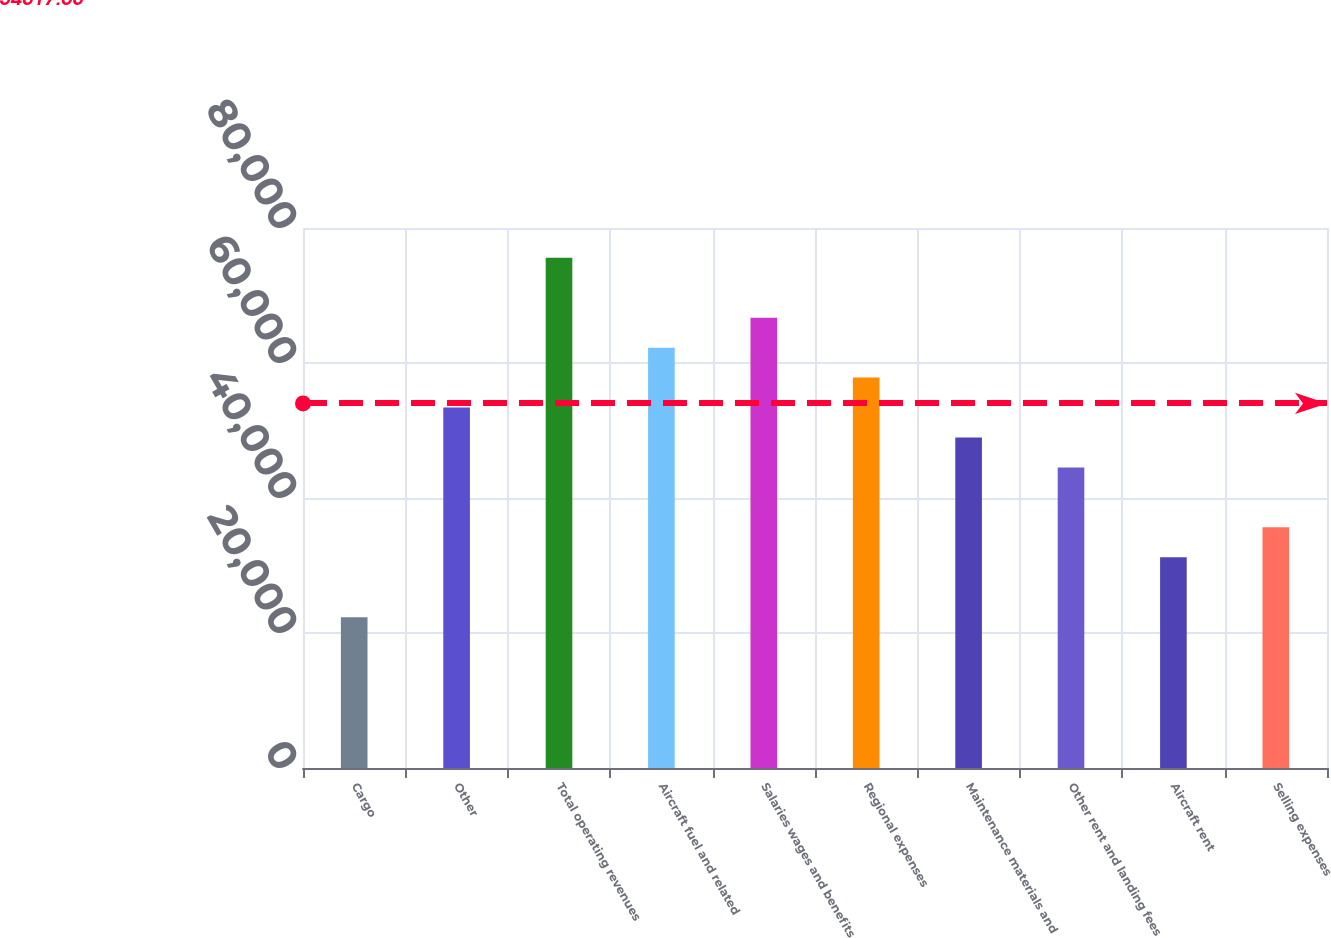<chart> <loc_0><loc_0><loc_500><loc_500><bar_chart><fcel>Cargo<fcel>Other<fcel>Total operating revenues<fcel>Aircraft fuel and related<fcel>Salaries wages and benefits<fcel>Regional expenses<fcel>Maintenance materials and<fcel>Other rent and landing fees<fcel>Aircraft rent<fcel>Selling expenses<nl><fcel>22348.5<fcel>53402.6<fcel>75584.1<fcel>62275.2<fcel>66711.5<fcel>57838.9<fcel>48966.3<fcel>44530<fcel>31221.1<fcel>35657.4<nl></chart> 